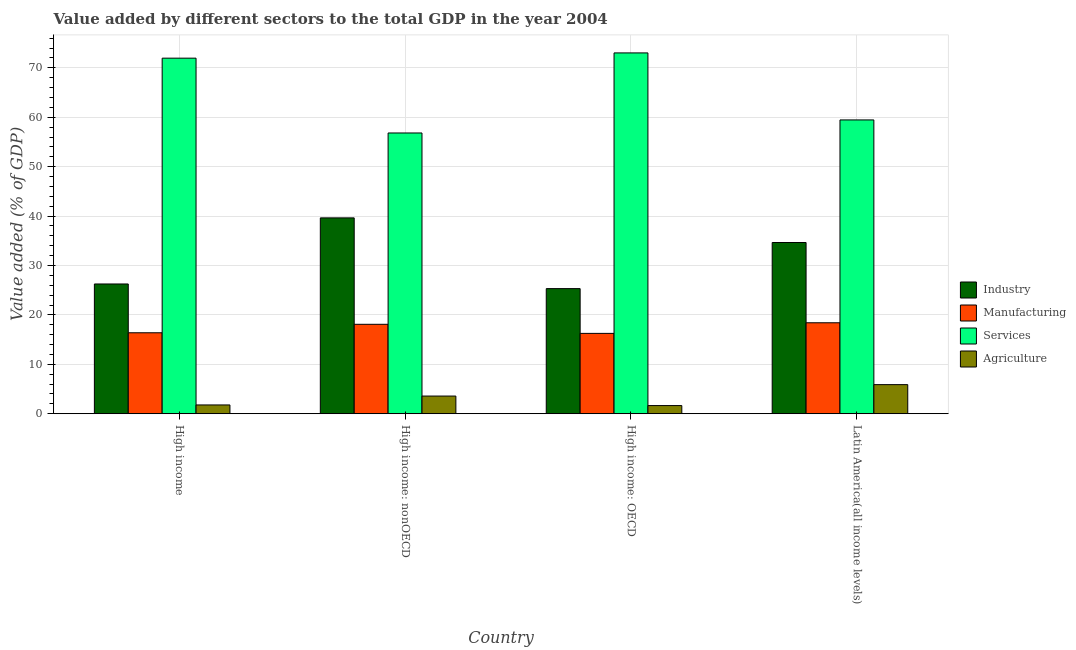How many bars are there on the 1st tick from the right?
Keep it short and to the point. 4. What is the label of the 3rd group of bars from the left?
Your response must be concise. High income: OECD. What is the value added by agricultural sector in High income: OECD?
Provide a short and direct response. 1.65. Across all countries, what is the maximum value added by industrial sector?
Your answer should be very brief. 39.64. Across all countries, what is the minimum value added by services sector?
Provide a short and direct response. 56.82. In which country was the value added by agricultural sector maximum?
Keep it short and to the point. Latin America(all income levels). In which country was the value added by manufacturing sector minimum?
Make the answer very short. High income: OECD. What is the total value added by industrial sector in the graph?
Ensure brevity in your answer.  125.87. What is the difference between the value added by services sector in High income: OECD and that in Latin America(all income levels)?
Offer a very short reply. 13.56. What is the difference between the value added by industrial sector in High income: OECD and the value added by services sector in High income?
Make the answer very short. -46.64. What is the average value added by industrial sector per country?
Your answer should be compact. 31.47. What is the difference between the value added by services sector and value added by agricultural sector in High income: nonOECD?
Provide a short and direct response. 53.24. In how many countries, is the value added by manufacturing sector greater than 74 %?
Offer a terse response. 0. What is the ratio of the value added by agricultural sector in High income: OECD to that in High income: nonOECD?
Keep it short and to the point. 0.46. Is the difference between the value added by industrial sector in High income: nonOECD and Latin America(all income levels) greater than the difference between the value added by agricultural sector in High income: nonOECD and Latin America(all income levels)?
Give a very brief answer. Yes. What is the difference between the highest and the second highest value added by agricultural sector?
Give a very brief answer. 2.31. What is the difference between the highest and the lowest value added by services sector?
Provide a succinct answer. 16.2. Is the sum of the value added by services sector in High income: OECD and High income: nonOECD greater than the maximum value added by agricultural sector across all countries?
Give a very brief answer. Yes. What does the 1st bar from the left in High income: OECD represents?
Give a very brief answer. Industry. What does the 2nd bar from the right in High income: OECD represents?
Provide a short and direct response. Services. Is it the case that in every country, the sum of the value added by industrial sector and value added by manufacturing sector is greater than the value added by services sector?
Your response must be concise. No. How many bars are there?
Give a very brief answer. 16. How many countries are there in the graph?
Your answer should be very brief. 4. How many legend labels are there?
Keep it short and to the point. 4. How are the legend labels stacked?
Your answer should be very brief. Vertical. What is the title of the graph?
Make the answer very short. Value added by different sectors to the total GDP in the year 2004. What is the label or title of the Y-axis?
Keep it short and to the point. Value added (% of GDP). What is the Value added (% of GDP) in Industry in High income?
Ensure brevity in your answer.  26.26. What is the Value added (% of GDP) of Manufacturing in High income?
Your answer should be compact. 16.38. What is the Value added (% of GDP) of Services in High income?
Give a very brief answer. 71.96. What is the Value added (% of GDP) of Agriculture in High income?
Your response must be concise. 1.78. What is the Value added (% of GDP) of Industry in High income: nonOECD?
Provide a succinct answer. 39.64. What is the Value added (% of GDP) of Manufacturing in High income: nonOECD?
Your answer should be compact. 18.1. What is the Value added (% of GDP) of Services in High income: nonOECD?
Your answer should be compact. 56.82. What is the Value added (% of GDP) in Agriculture in High income: nonOECD?
Your response must be concise. 3.58. What is the Value added (% of GDP) in Industry in High income: OECD?
Offer a terse response. 25.32. What is the Value added (% of GDP) of Manufacturing in High income: OECD?
Provide a short and direct response. 16.26. What is the Value added (% of GDP) of Services in High income: OECD?
Provide a short and direct response. 73.02. What is the Value added (% of GDP) of Agriculture in High income: OECD?
Give a very brief answer. 1.65. What is the Value added (% of GDP) in Industry in Latin America(all income levels)?
Your answer should be very brief. 34.65. What is the Value added (% of GDP) of Manufacturing in Latin America(all income levels)?
Make the answer very short. 18.41. What is the Value added (% of GDP) in Services in Latin America(all income levels)?
Make the answer very short. 59.46. What is the Value added (% of GDP) in Agriculture in Latin America(all income levels)?
Make the answer very short. 5.89. Across all countries, what is the maximum Value added (% of GDP) of Industry?
Ensure brevity in your answer.  39.64. Across all countries, what is the maximum Value added (% of GDP) of Manufacturing?
Provide a short and direct response. 18.41. Across all countries, what is the maximum Value added (% of GDP) in Services?
Your response must be concise. 73.02. Across all countries, what is the maximum Value added (% of GDP) in Agriculture?
Your answer should be very brief. 5.89. Across all countries, what is the minimum Value added (% of GDP) in Industry?
Offer a very short reply. 25.32. Across all countries, what is the minimum Value added (% of GDP) in Manufacturing?
Give a very brief answer. 16.26. Across all countries, what is the minimum Value added (% of GDP) in Services?
Keep it short and to the point. 56.82. Across all countries, what is the minimum Value added (% of GDP) in Agriculture?
Your answer should be very brief. 1.65. What is the total Value added (% of GDP) in Industry in the graph?
Keep it short and to the point. 125.87. What is the total Value added (% of GDP) in Manufacturing in the graph?
Provide a short and direct response. 69.16. What is the total Value added (% of GDP) of Services in the graph?
Provide a short and direct response. 261.26. What is the total Value added (% of GDP) in Agriculture in the graph?
Make the answer very short. 12.9. What is the difference between the Value added (% of GDP) in Industry in High income and that in High income: nonOECD?
Provide a succinct answer. -13.38. What is the difference between the Value added (% of GDP) of Manufacturing in High income and that in High income: nonOECD?
Make the answer very short. -1.72. What is the difference between the Value added (% of GDP) of Services in High income and that in High income: nonOECD?
Give a very brief answer. 15.14. What is the difference between the Value added (% of GDP) of Agriculture in High income and that in High income: nonOECD?
Give a very brief answer. -1.8. What is the difference between the Value added (% of GDP) of Industry in High income and that in High income: OECD?
Keep it short and to the point. 0.94. What is the difference between the Value added (% of GDP) of Manufacturing in High income and that in High income: OECD?
Ensure brevity in your answer.  0.12. What is the difference between the Value added (% of GDP) of Services in High income and that in High income: OECD?
Give a very brief answer. -1.06. What is the difference between the Value added (% of GDP) of Agriculture in High income and that in High income: OECD?
Ensure brevity in your answer.  0.13. What is the difference between the Value added (% of GDP) in Industry in High income and that in Latin America(all income levels)?
Make the answer very short. -8.39. What is the difference between the Value added (% of GDP) in Manufacturing in High income and that in Latin America(all income levels)?
Ensure brevity in your answer.  -2.03. What is the difference between the Value added (% of GDP) of Services in High income and that in Latin America(all income levels)?
Your answer should be compact. 12.5. What is the difference between the Value added (% of GDP) of Agriculture in High income and that in Latin America(all income levels)?
Your answer should be compact. -4.11. What is the difference between the Value added (% of GDP) in Industry in High income: nonOECD and that in High income: OECD?
Give a very brief answer. 14.31. What is the difference between the Value added (% of GDP) in Manufacturing in High income: nonOECD and that in High income: OECD?
Your answer should be compact. 1.84. What is the difference between the Value added (% of GDP) of Services in High income: nonOECD and that in High income: OECD?
Offer a terse response. -16.2. What is the difference between the Value added (% of GDP) of Agriculture in High income: nonOECD and that in High income: OECD?
Offer a terse response. 1.92. What is the difference between the Value added (% of GDP) in Industry in High income: nonOECD and that in Latin America(all income levels)?
Provide a short and direct response. 4.99. What is the difference between the Value added (% of GDP) of Manufacturing in High income: nonOECD and that in Latin America(all income levels)?
Your response must be concise. -0.31. What is the difference between the Value added (% of GDP) in Services in High income: nonOECD and that in Latin America(all income levels)?
Keep it short and to the point. -2.64. What is the difference between the Value added (% of GDP) in Agriculture in High income: nonOECD and that in Latin America(all income levels)?
Give a very brief answer. -2.31. What is the difference between the Value added (% of GDP) in Industry in High income: OECD and that in Latin America(all income levels)?
Offer a very short reply. -9.33. What is the difference between the Value added (% of GDP) in Manufacturing in High income: OECD and that in Latin America(all income levels)?
Give a very brief answer. -2.15. What is the difference between the Value added (% of GDP) in Services in High income: OECD and that in Latin America(all income levels)?
Your response must be concise. 13.56. What is the difference between the Value added (% of GDP) of Agriculture in High income: OECD and that in Latin America(all income levels)?
Your answer should be very brief. -4.23. What is the difference between the Value added (% of GDP) in Industry in High income and the Value added (% of GDP) in Manufacturing in High income: nonOECD?
Give a very brief answer. 8.16. What is the difference between the Value added (% of GDP) in Industry in High income and the Value added (% of GDP) in Services in High income: nonOECD?
Offer a very short reply. -30.56. What is the difference between the Value added (% of GDP) in Industry in High income and the Value added (% of GDP) in Agriculture in High income: nonOECD?
Your response must be concise. 22.68. What is the difference between the Value added (% of GDP) of Manufacturing in High income and the Value added (% of GDP) of Services in High income: nonOECD?
Your answer should be compact. -40.44. What is the difference between the Value added (% of GDP) of Manufacturing in High income and the Value added (% of GDP) of Agriculture in High income: nonOECD?
Your answer should be very brief. 12.81. What is the difference between the Value added (% of GDP) of Services in High income and the Value added (% of GDP) of Agriculture in High income: nonOECD?
Offer a very short reply. 68.38. What is the difference between the Value added (% of GDP) in Industry in High income and the Value added (% of GDP) in Manufacturing in High income: OECD?
Provide a succinct answer. 10. What is the difference between the Value added (% of GDP) of Industry in High income and the Value added (% of GDP) of Services in High income: OECD?
Offer a terse response. -46.76. What is the difference between the Value added (% of GDP) of Industry in High income and the Value added (% of GDP) of Agriculture in High income: OECD?
Your answer should be very brief. 24.61. What is the difference between the Value added (% of GDP) of Manufacturing in High income and the Value added (% of GDP) of Services in High income: OECD?
Your response must be concise. -56.64. What is the difference between the Value added (% of GDP) in Manufacturing in High income and the Value added (% of GDP) in Agriculture in High income: OECD?
Your answer should be compact. 14.73. What is the difference between the Value added (% of GDP) in Services in High income and the Value added (% of GDP) in Agriculture in High income: OECD?
Offer a very short reply. 70.31. What is the difference between the Value added (% of GDP) in Industry in High income and the Value added (% of GDP) in Manufacturing in Latin America(all income levels)?
Provide a short and direct response. 7.85. What is the difference between the Value added (% of GDP) of Industry in High income and the Value added (% of GDP) of Services in Latin America(all income levels)?
Make the answer very short. -33.2. What is the difference between the Value added (% of GDP) of Industry in High income and the Value added (% of GDP) of Agriculture in Latin America(all income levels)?
Offer a very short reply. 20.37. What is the difference between the Value added (% of GDP) of Manufacturing in High income and the Value added (% of GDP) of Services in Latin America(all income levels)?
Ensure brevity in your answer.  -43.08. What is the difference between the Value added (% of GDP) of Manufacturing in High income and the Value added (% of GDP) of Agriculture in Latin America(all income levels)?
Make the answer very short. 10.5. What is the difference between the Value added (% of GDP) of Services in High income and the Value added (% of GDP) of Agriculture in Latin America(all income levels)?
Make the answer very short. 66.07. What is the difference between the Value added (% of GDP) in Industry in High income: nonOECD and the Value added (% of GDP) in Manufacturing in High income: OECD?
Provide a short and direct response. 23.37. What is the difference between the Value added (% of GDP) of Industry in High income: nonOECD and the Value added (% of GDP) of Services in High income: OECD?
Keep it short and to the point. -33.38. What is the difference between the Value added (% of GDP) in Industry in High income: nonOECD and the Value added (% of GDP) in Agriculture in High income: OECD?
Offer a very short reply. 37.98. What is the difference between the Value added (% of GDP) in Manufacturing in High income: nonOECD and the Value added (% of GDP) in Services in High income: OECD?
Provide a succinct answer. -54.92. What is the difference between the Value added (% of GDP) in Manufacturing in High income: nonOECD and the Value added (% of GDP) in Agriculture in High income: OECD?
Give a very brief answer. 16.45. What is the difference between the Value added (% of GDP) of Services in High income: nonOECD and the Value added (% of GDP) of Agriculture in High income: OECD?
Give a very brief answer. 55.17. What is the difference between the Value added (% of GDP) of Industry in High income: nonOECD and the Value added (% of GDP) of Manufacturing in Latin America(all income levels)?
Your answer should be very brief. 21.23. What is the difference between the Value added (% of GDP) in Industry in High income: nonOECD and the Value added (% of GDP) in Services in Latin America(all income levels)?
Your response must be concise. -19.82. What is the difference between the Value added (% of GDP) in Industry in High income: nonOECD and the Value added (% of GDP) in Agriculture in Latin America(all income levels)?
Your response must be concise. 33.75. What is the difference between the Value added (% of GDP) of Manufacturing in High income: nonOECD and the Value added (% of GDP) of Services in Latin America(all income levels)?
Your answer should be very brief. -41.36. What is the difference between the Value added (% of GDP) of Manufacturing in High income: nonOECD and the Value added (% of GDP) of Agriculture in Latin America(all income levels)?
Provide a succinct answer. 12.21. What is the difference between the Value added (% of GDP) of Services in High income: nonOECD and the Value added (% of GDP) of Agriculture in Latin America(all income levels)?
Offer a very short reply. 50.93. What is the difference between the Value added (% of GDP) in Industry in High income: OECD and the Value added (% of GDP) in Manufacturing in Latin America(all income levels)?
Your response must be concise. 6.91. What is the difference between the Value added (% of GDP) in Industry in High income: OECD and the Value added (% of GDP) in Services in Latin America(all income levels)?
Your answer should be very brief. -34.14. What is the difference between the Value added (% of GDP) in Industry in High income: OECD and the Value added (% of GDP) in Agriculture in Latin America(all income levels)?
Your response must be concise. 19.43. What is the difference between the Value added (% of GDP) of Manufacturing in High income: OECD and the Value added (% of GDP) of Services in Latin America(all income levels)?
Make the answer very short. -43.2. What is the difference between the Value added (% of GDP) in Manufacturing in High income: OECD and the Value added (% of GDP) in Agriculture in Latin America(all income levels)?
Provide a succinct answer. 10.37. What is the difference between the Value added (% of GDP) in Services in High income: OECD and the Value added (% of GDP) in Agriculture in Latin America(all income levels)?
Offer a terse response. 67.13. What is the average Value added (% of GDP) in Industry per country?
Give a very brief answer. 31.47. What is the average Value added (% of GDP) of Manufacturing per country?
Offer a very short reply. 17.29. What is the average Value added (% of GDP) of Services per country?
Make the answer very short. 65.32. What is the average Value added (% of GDP) of Agriculture per country?
Keep it short and to the point. 3.23. What is the difference between the Value added (% of GDP) in Industry and Value added (% of GDP) in Manufacturing in High income?
Offer a very short reply. 9.88. What is the difference between the Value added (% of GDP) of Industry and Value added (% of GDP) of Services in High income?
Make the answer very short. -45.7. What is the difference between the Value added (% of GDP) in Industry and Value added (% of GDP) in Agriculture in High income?
Offer a very short reply. 24.48. What is the difference between the Value added (% of GDP) in Manufacturing and Value added (% of GDP) in Services in High income?
Offer a terse response. -55.58. What is the difference between the Value added (% of GDP) of Manufacturing and Value added (% of GDP) of Agriculture in High income?
Offer a very short reply. 14.6. What is the difference between the Value added (% of GDP) in Services and Value added (% of GDP) in Agriculture in High income?
Offer a very short reply. 70.18. What is the difference between the Value added (% of GDP) in Industry and Value added (% of GDP) in Manufacturing in High income: nonOECD?
Your answer should be compact. 21.54. What is the difference between the Value added (% of GDP) of Industry and Value added (% of GDP) of Services in High income: nonOECD?
Provide a short and direct response. -17.18. What is the difference between the Value added (% of GDP) in Industry and Value added (% of GDP) in Agriculture in High income: nonOECD?
Your answer should be compact. 36.06. What is the difference between the Value added (% of GDP) in Manufacturing and Value added (% of GDP) in Services in High income: nonOECD?
Ensure brevity in your answer.  -38.72. What is the difference between the Value added (% of GDP) of Manufacturing and Value added (% of GDP) of Agriculture in High income: nonOECD?
Ensure brevity in your answer.  14.52. What is the difference between the Value added (% of GDP) in Services and Value added (% of GDP) in Agriculture in High income: nonOECD?
Offer a very short reply. 53.24. What is the difference between the Value added (% of GDP) of Industry and Value added (% of GDP) of Manufacturing in High income: OECD?
Your response must be concise. 9.06. What is the difference between the Value added (% of GDP) in Industry and Value added (% of GDP) in Services in High income: OECD?
Provide a short and direct response. -47.7. What is the difference between the Value added (% of GDP) of Industry and Value added (% of GDP) of Agriculture in High income: OECD?
Provide a short and direct response. 23.67. What is the difference between the Value added (% of GDP) of Manufacturing and Value added (% of GDP) of Services in High income: OECD?
Offer a terse response. -56.76. What is the difference between the Value added (% of GDP) of Manufacturing and Value added (% of GDP) of Agriculture in High income: OECD?
Offer a terse response. 14.61. What is the difference between the Value added (% of GDP) of Services and Value added (% of GDP) of Agriculture in High income: OECD?
Your answer should be compact. 71.37. What is the difference between the Value added (% of GDP) of Industry and Value added (% of GDP) of Manufacturing in Latin America(all income levels)?
Offer a very short reply. 16.24. What is the difference between the Value added (% of GDP) in Industry and Value added (% of GDP) in Services in Latin America(all income levels)?
Make the answer very short. -24.81. What is the difference between the Value added (% of GDP) of Industry and Value added (% of GDP) of Agriculture in Latin America(all income levels)?
Give a very brief answer. 28.76. What is the difference between the Value added (% of GDP) in Manufacturing and Value added (% of GDP) in Services in Latin America(all income levels)?
Give a very brief answer. -41.05. What is the difference between the Value added (% of GDP) of Manufacturing and Value added (% of GDP) of Agriculture in Latin America(all income levels)?
Make the answer very short. 12.52. What is the difference between the Value added (% of GDP) in Services and Value added (% of GDP) in Agriculture in Latin America(all income levels)?
Give a very brief answer. 53.57. What is the ratio of the Value added (% of GDP) of Industry in High income to that in High income: nonOECD?
Give a very brief answer. 0.66. What is the ratio of the Value added (% of GDP) in Manufacturing in High income to that in High income: nonOECD?
Keep it short and to the point. 0.91. What is the ratio of the Value added (% of GDP) of Services in High income to that in High income: nonOECD?
Your response must be concise. 1.27. What is the ratio of the Value added (% of GDP) in Agriculture in High income to that in High income: nonOECD?
Make the answer very short. 0.5. What is the ratio of the Value added (% of GDP) in Industry in High income to that in High income: OECD?
Ensure brevity in your answer.  1.04. What is the ratio of the Value added (% of GDP) of Manufacturing in High income to that in High income: OECD?
Make the answer very short. 1.01. What is the ratio of the Value added (% of GDP) in Services in High income to that in High income: OECD?
Your answer should be compact. 0.99. What is the ratio of the Value added (% of GDP) of Agriculture in High income to that in High income: OECD?
Keep it short and to the point. 1.08. What is the ratio of the Value added (% of GDP) in Industry in High income to that in Latin America(all income levels)?
Keep it short and to the point. 0.76. What is the ratio of the Value added (% of GDP) in Manufacturing in High income to that in Latin America(all income levels)?
Make the answer very short. 0.89. What is the ratio of the Value added (% of GDP) in Services in High income to that in Latin America(all income levels)?
Give a very brief answer. 1.21. What is the ratio of the Value added (% of GDP) in Agriculture in High income to that in Latin America(all income levels)?
Provide a short and direct response. 0.3. What is the ratio of the Value added (% of GDP) in Industry in High income: nonOECD to that in High income: OECD?
Your response must be concise. 1.57. What is the ratio of the Value added (% of GDP) of Manufacturing in High income: nonOECD to that in High income: OECD?
Provide a succinct answer. 1.11. What is the ratio of the Value added (% of GDP) of Services in High income: nonOECD to that in High income: OECD?
Offer a terse response. 0.78. What is the ratio of the Value added (% of GDP) in Agriculture in High income: nonOECD to that in High income: OECD?
Provide a succinct answer. 2.16. What is the ratio of the Value added (% of GDP) of Industry in High income: nonOECD to that in Latin America(all income levels)?
Offer a terse response. 1.14. What is the ratio of the Value added (% of GDP) of Manufacturing in High income: nonOECD to that in Latin America(all income levels)?
Ensure brevity in your answer.  0.98. What is the ratio of the Value added (% of GDP) of Services in High income: nonOECD to that in Latin America(all income levels)?
Your answer should be compact. 0.96. What is the ratio of the Value added (% of GDP) of Agriculture in High income: nonOECD to that in Latin America(all income levels)?
Make the answer very short. 0.61. What is the ratio of the Value added (% of GDP) in Industry in High income: OECD to that in Latin America(all income levels)?
Ensure brevity in your answer.  0.73. What is the ratio of the Value added (% of GDP) in Manufacturing in High income: OECD to that in Latin America(all income levels)?
Your response must be concise. 0.88. What is the ratio of the Value added (% of GDP) of Services in High income: OECD to that in Latin America(all income levels)?
Your response must be concise. 1.23. What is the ratio of the Value added (% of GDP) of Agriculture in High income: OECD to that in Latin America(all income levels)?
Offer a very short reply. 0.28. What is the difference between the highest and the second highest Value added (% of GDP) of Industry?
Provide a succinct answer. 4.99. What is the difference between the highest and the second highest Value added (% of GDP) of Manufacturing?
Give a very brief answer. 0.31. What is the difference between the highest and the second highest Value added (% of GDP) of Services?
Ensure brevity in your answer.  1.06. What is the difference between the highest and the second highest Value added (% of GDP) in Agriculture?
Offer a terse response. 2.31. What is the difference between the highest and the lowest Value added (% of GDP) of Industry?
Your response must be concise. 14.31. What is the difference between the highest and the lowest Value added (% of GDP) of Manufacturing?
Your response must be concise. 2.15. What is the difference between the highest and the lowest Value added (% of GDP) in Services?
Make the answer very short. 16.2. What is the difference between the highest and the lowest Value added (% of GDP) in Agriculture?
Your answer should be very brief. 4.23. 